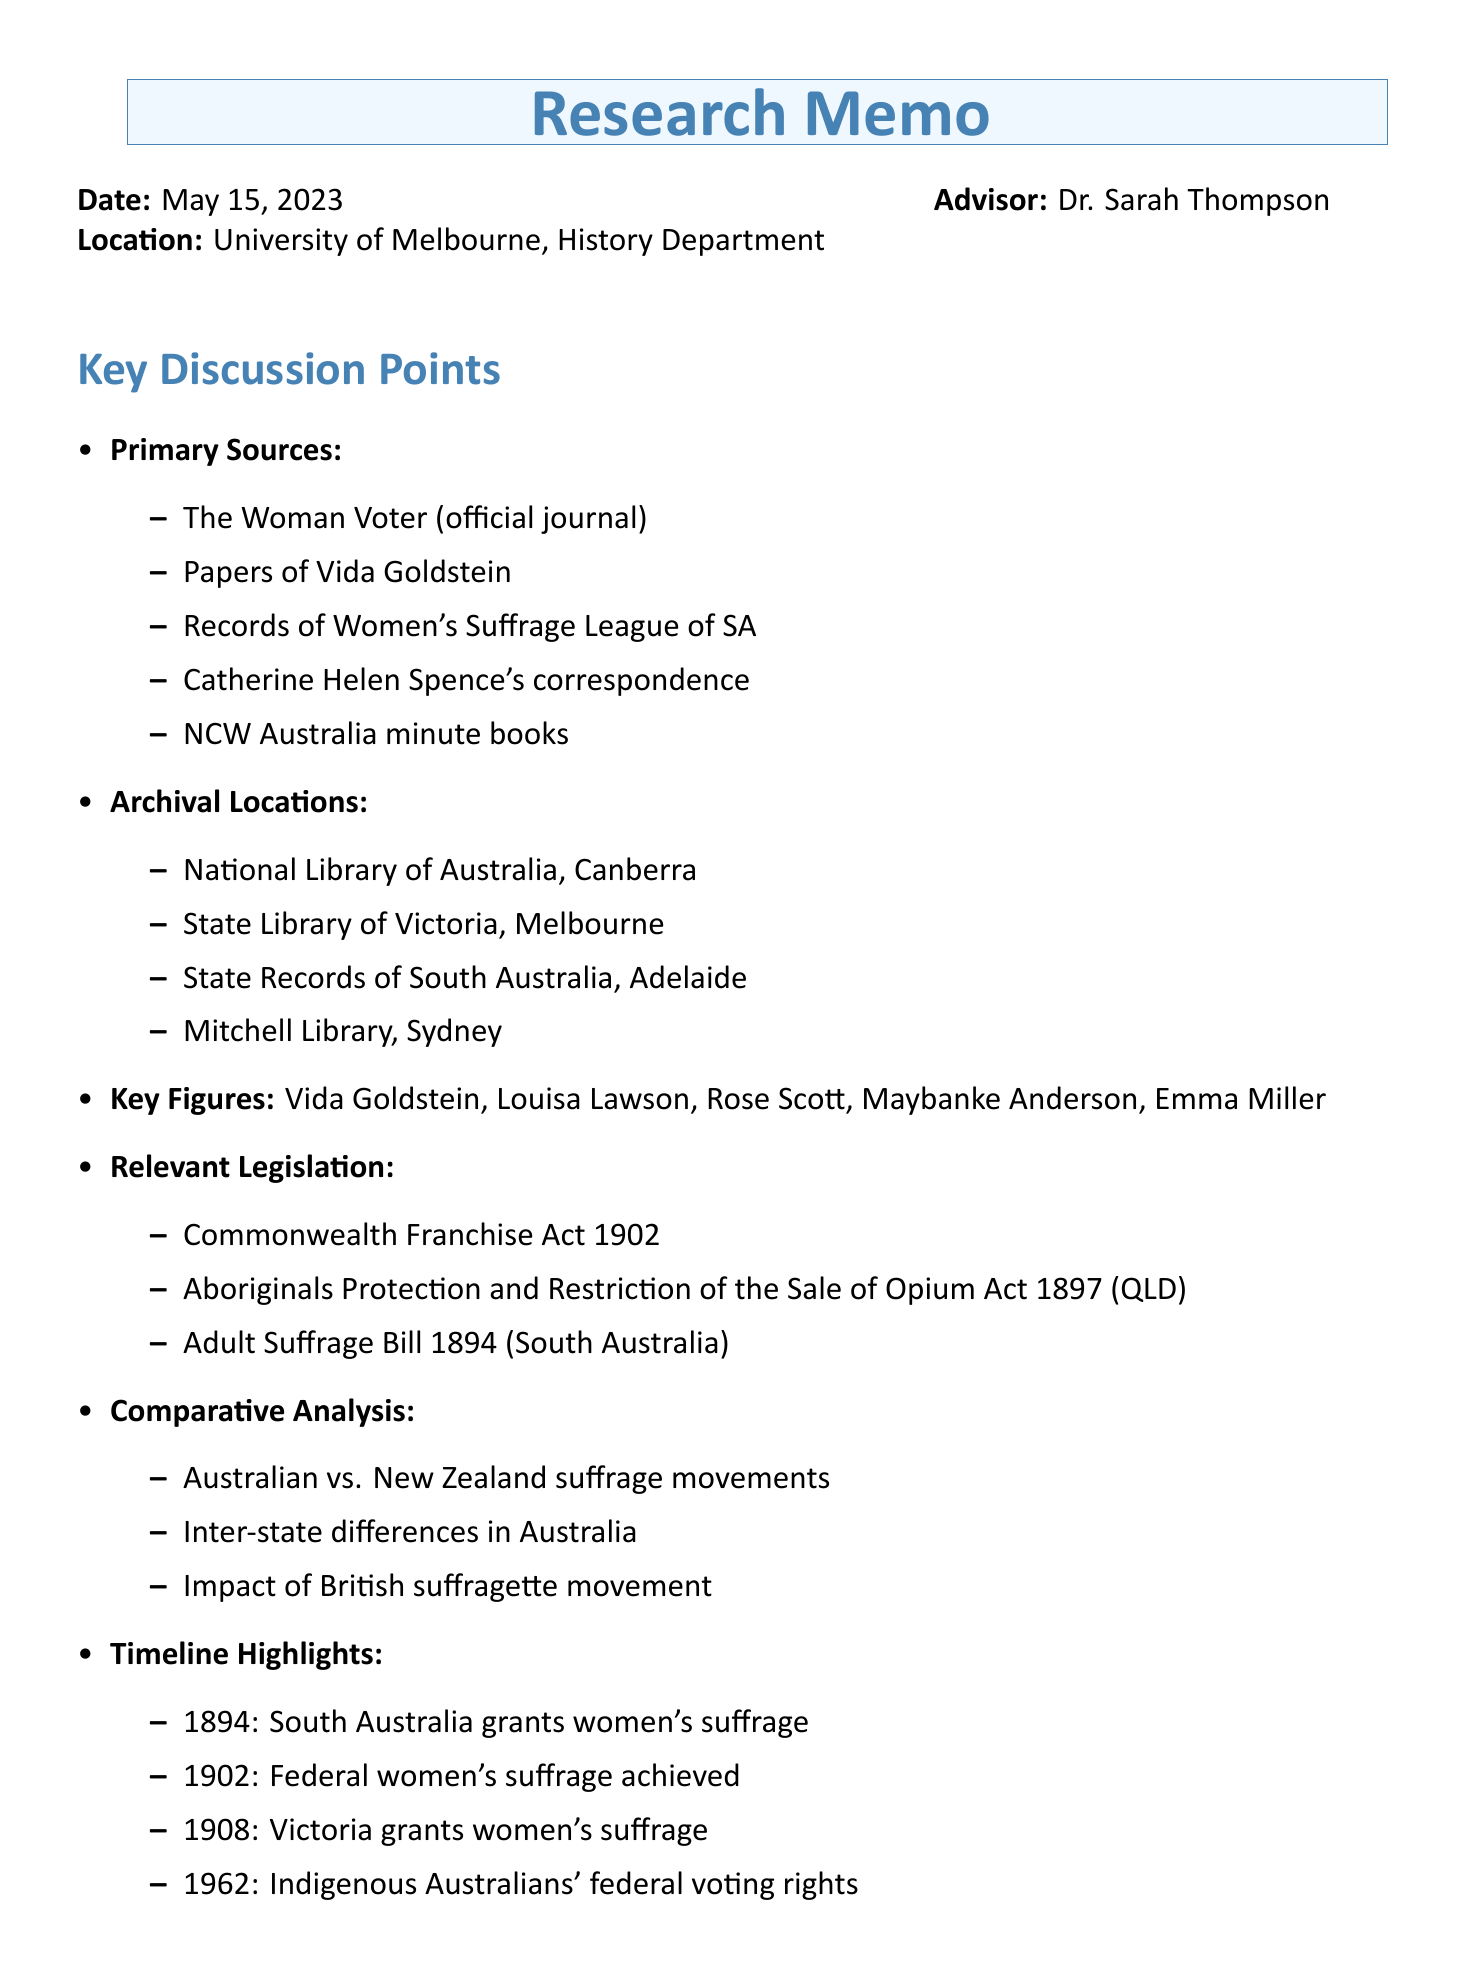What is the date of the meeting? The date of the meeting is specified in the memo as May 15, 2023.
Answer: May 15, 2023 Who is the advisor mentioned in the memo? The memo lists Dr. Sarah Thompson as the advisor present at the meeting.
Answer: Dr. Sarah Thompson What is one of the primary sources suggested for research? The memo highlights "The Woman Voter" as one potential primary source for suffrage research.
Answer: The Woman Voter Which legislation relates to women's suffrage in Australia? The Commonwealth Franchise Act 1902 is noted as a relevant legislation in the document.
Answer: Commonwealth Franchise Act 1902 What action item involves accessing Vida Goldstein papers? One of the action items is to "Contact National Library of Australia to arrange access to Vida Goldstein papers."
Answer: Contact National Library of Australia How many key figures to research are listed? The document lists five key figures to research related to the suffrage movement.
Answer: Five What event marked the granting of women's suffrage in South Australia? The memo states that in 1894, South Australia granted women's suffrage.
Answer: 1894: South Australia grants women's suffrage What type of analysis is suggested in the discussion points? The document suggests a comparative analysis of Australian suffrage with other movements.
Answer: Comparative analysis What kind of resources are included at the end of the memo? The memo provides additional resources for further exploration of women's suffrage history.
Answer: Additional resources 